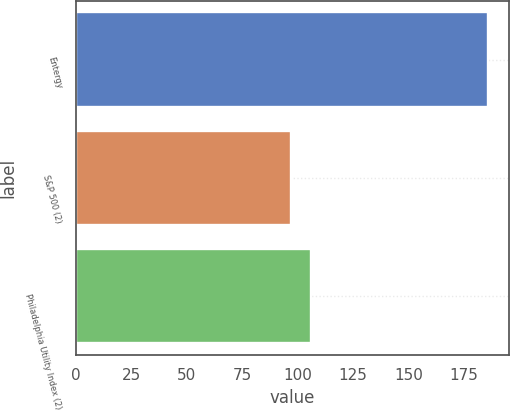<chart> <loc_0><loc_0><loc_500><loc_500><bar_chart><fcel>Entergy<fcel>S&P 500 (2)<fcel>Philadelphia Utility Index (2)<nl><fcel>185.9<fcel>97.12<fcel>106<nl></chart> 